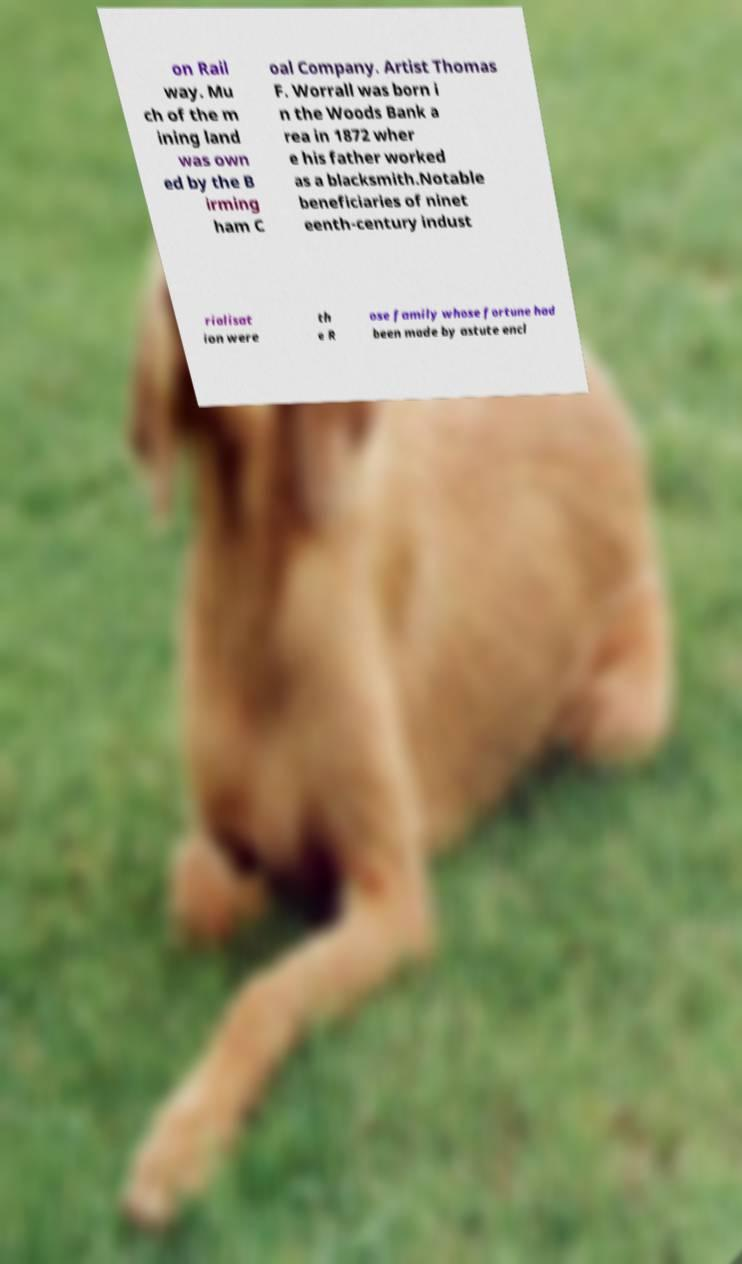Could you extract and type out the text from this image? on Rail way. Mu ch of the m ining land was own ed by the B irming ham C oal Company. Artist Thomas F. Worrall was born i n the Woods Bank a rea in 1872 wher e his father worked as a blacksmith.Notable beneficiaries of ninet eenth-century indust rialisat ion were th e R ose family whose fortune had been made by astute encl 